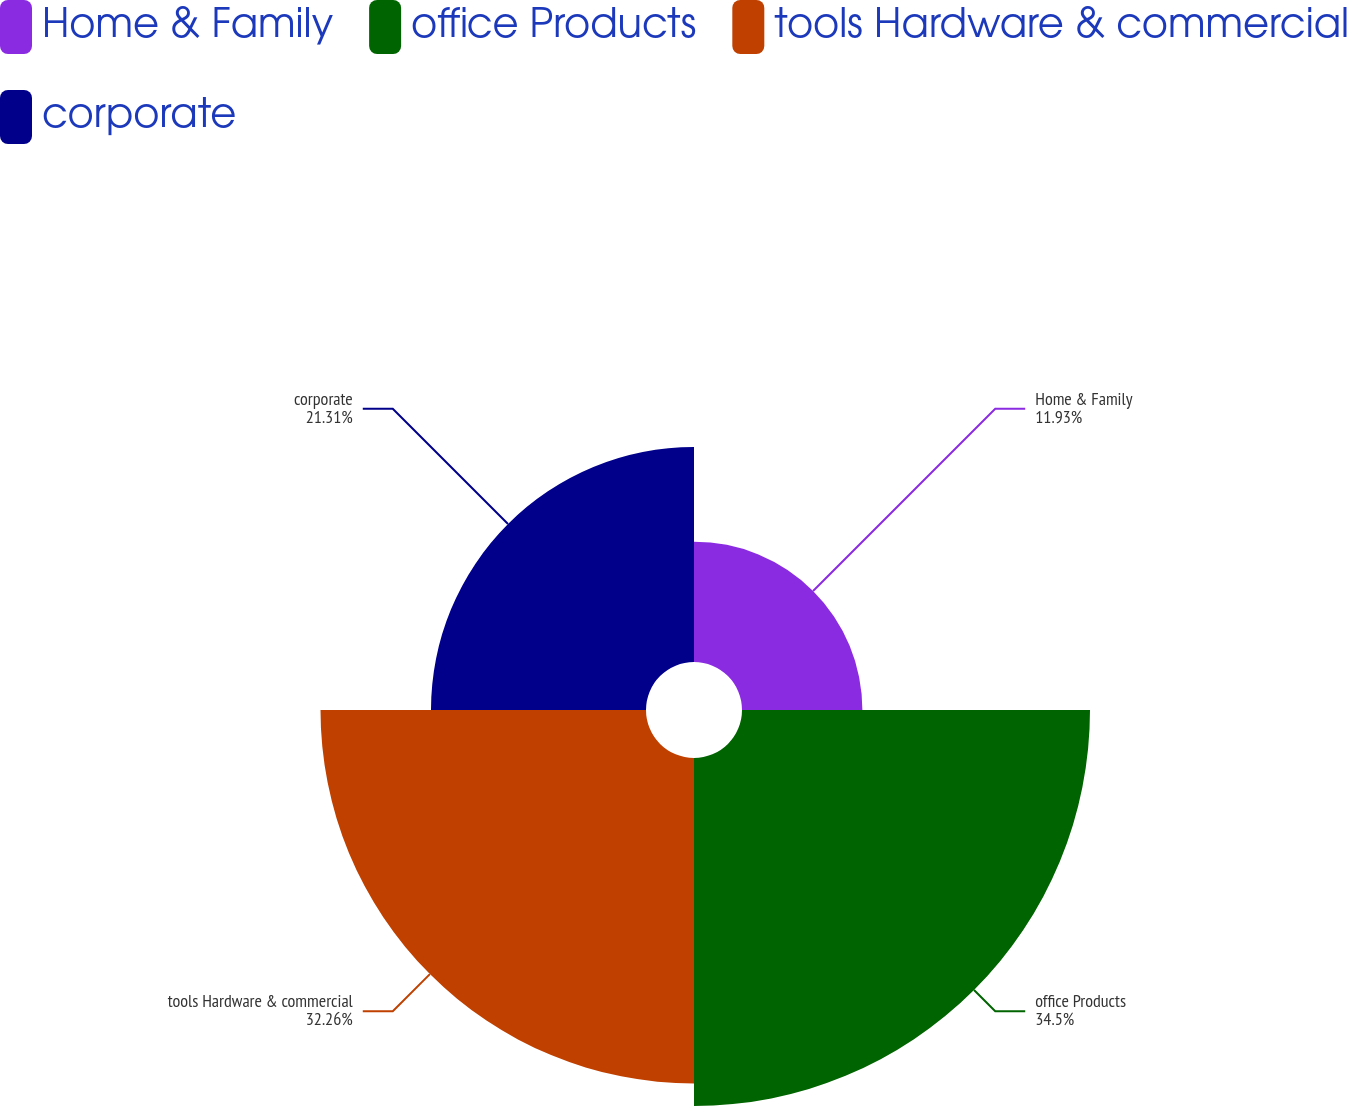Convert chart. <chart><loc_0><loc_0><loc_500><loc_500><pie_chart><fcel>Home & Family<fcel>office Products<fcel>tools Hardware & commercial<fcel>corporate<nl><fcel>11.93%<fcel>34.49%<fcel>32.26%<fcel>21.31%<nl></chart> 